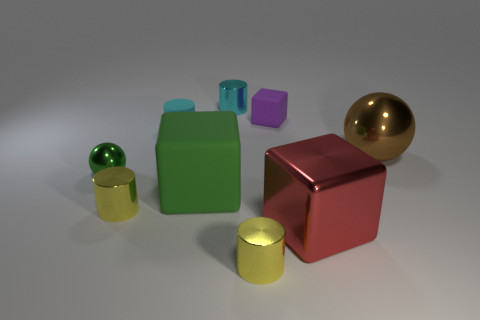Subtract all shiny cylinders. How many cylinders are left? 1 Subtract 1 cylinders. How many cylinders are left? 3 Subtract all red balls. How many red blocks are left? 1 Subtract all green blocks. How many blocks are left? 2 Subtract 0 gray cylinders. How many objects are left? 9 Subtract all cubes. How many objects are left? 6 Subtract all yellow cylinders. Subtract all brown spheres. How many cylinders are left? 2 Subtract all yellow balls. Subtract all tiny rubber cubes. How many objects are left? 8 Add 5 tiny cyan matte cylinders. How many tiny cyan matte cylinders are left? 6 Add 6 purple cubes. How many purple cubes exist? 7 